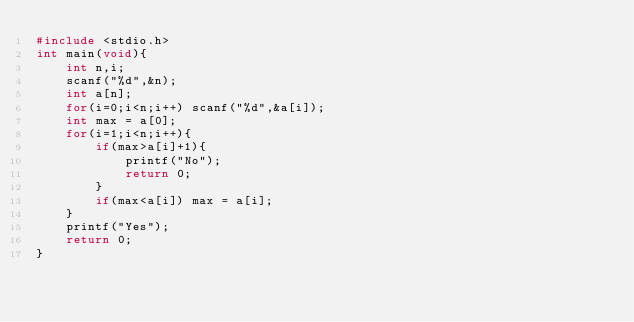Convert code to text. <code><loc_0><loc_0><loc_500><loc_500><_C_>#include <stdio.h>
int main(void){
    int n,i;
    scanf("%d",&n);
    int a[n];
    for(i=0;i<n;i++) scanf("%d",&a[i]);
    int max = a[0];
    for(i=1;i<n;i++){
        if(max>a[i]+1){
            printf("No");
            return 0;
        }
        if(max<a[i]) max = a[i];
    }
    printf("Yes");
    return 0;
}</code> 